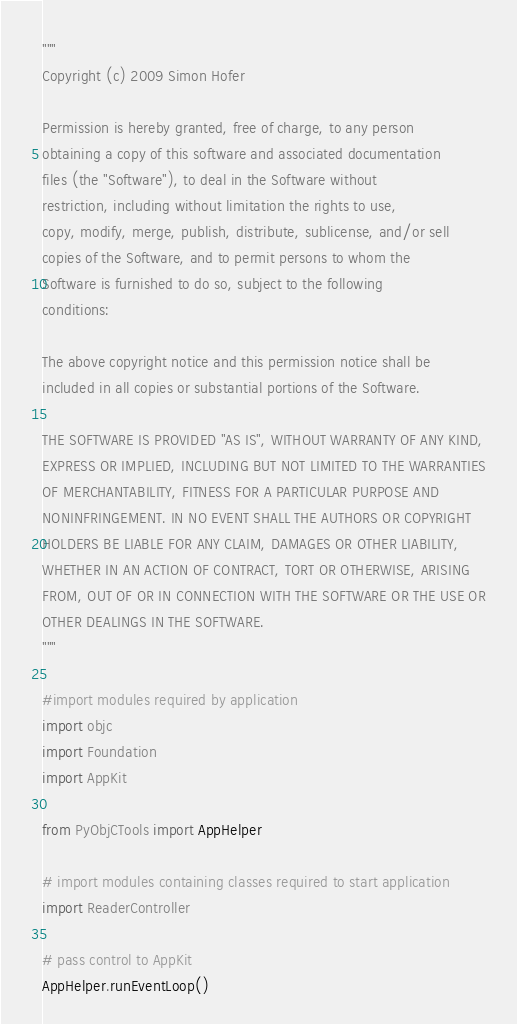Convert code to text. <code><loc_0><loc_0><loc_500><loc_500><_Python_>"""
Copyright (c) 2009 Simon Hofer

Permission is hereby granted, free of charge, to any person
obtaining a copy of this software and associated documentation
files (the "Software"), to deal in the Software without
restriction, including without limitation the rights to use,
copy, modify, merge, publish, distribute, sublicense, and/or sell
copies of the Software, and to permit persons to whom the
Software is furnished to do so, subject to the following
conditions:

The above copyright notice and this permission notice shall be
included in all copies or substantial portions of the Software.

THE SOFTWARE IS PROVIDED "AS IS", WITHOUT WARRANTY OF ANY KIND,
EXPRESS OR IMPLIED, INCLUDING BUT NOT LIMITED TO THE WARRANTIES
OF MERCHANTABILITY, FITNESS FOR A PARTICULAR PURPOSE AND
NONINFRINGEMENT. IN NO EVENT SHALL THE AUTHORS OR COPYRIGHT
HOLDERS BE LIABLE FOR ANY CLAIM, DAMAGES OR OTHER LIABILITY,
WHETHER IN AN ACTION OF CONTRACT, TORT OR OTHERWISE, ARISING
FROM, OUT OF OR IN CONNECTION WITH THE SOFTWARE OR THE USE OR
OTHER DEALINGS IN THE SOFTWARE.
"""

#import modules required by application
import objc
import Foundation
import AppKit

from PyObjCTools import AppHelper

# import modules containing classes required to start application
import ReaderController

# pass control to AppKit
AppHelper.runEventLoop()
</code> 